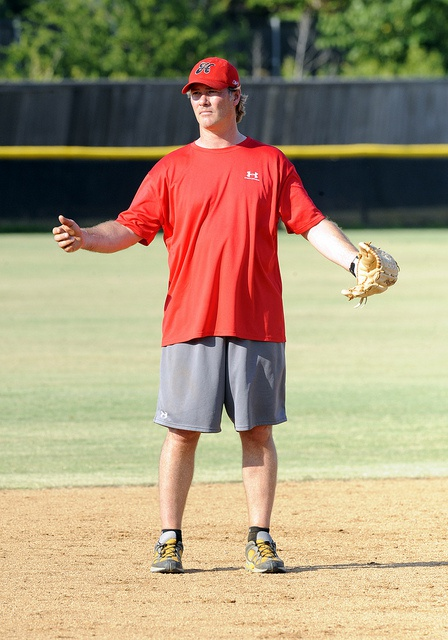Describe the objects in this image and their specific colors. I can see people in darkgreen, salmon, brown, lightgray, and red tones and baseball glove in darkgreen, beige, khaki, tan, and darkgray tones in this image. 